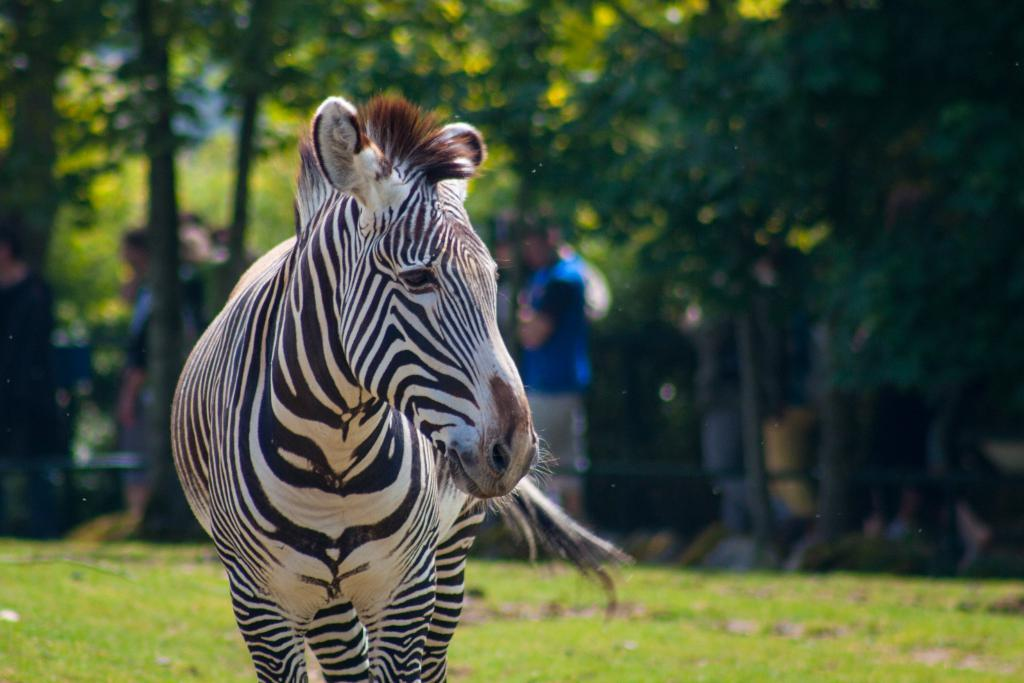What animal is on the left side of the image? There is a zebra on the left side of the image. What type of vegetation is at the bottom of the image? There is green grass at the bottom of the image. What can be seen in the background of the image? There are people and trees in the background of the image. What type of lock is holding the jar in the image? There is no lock or jar present in the image; it features a zebra, green grass, and people and trees in the background. 